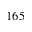Convert formula to latex. <formula><loc_0><loc_0><loc_500><loc_500>1 6 5</formula> 